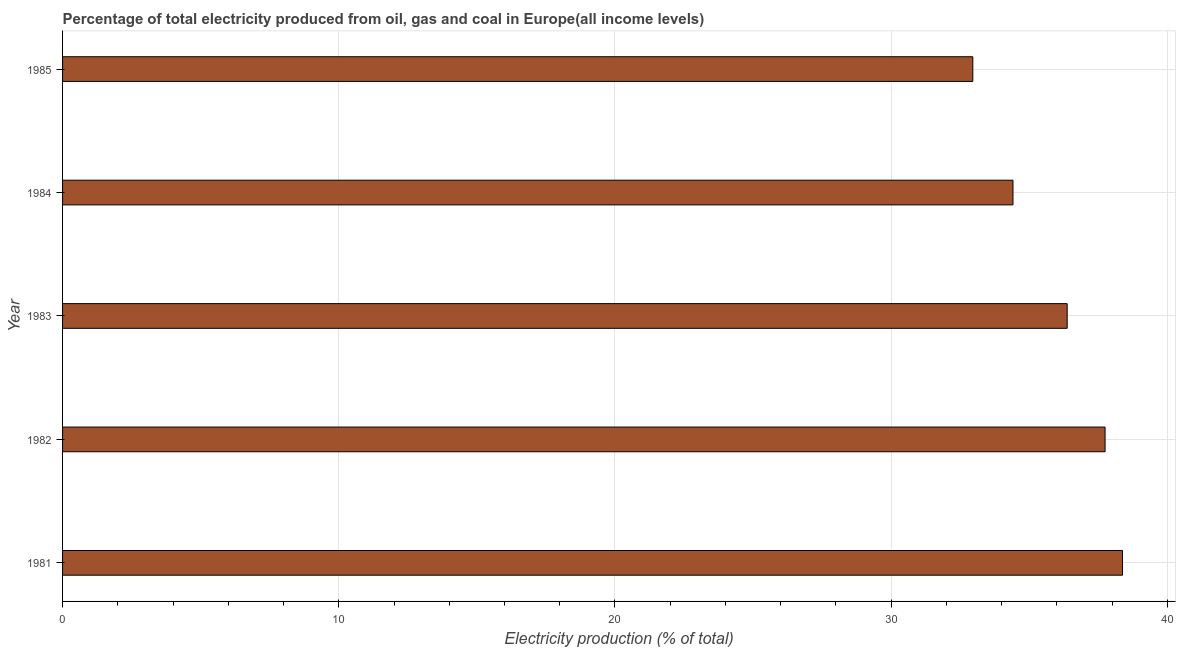Does the graph contain any zero values?
Give a very brief answer. No. What is the title of the graph?
Offer a terse response. Percentage of total electricity produced from oil, gas and coal in Europe(all income levels). What is the label or title of the X-axis?
Your answer should be very brief. Electricity production (% of total). What is the electricity production in 1985?
Your response must be concise. 32.95. Across all years, what is the maximum electricity production?
Keep it short and to the point. 38.37. Across all years, what is the minimum electricity production?
Provide a short and direct response. 32.95. In which year was the electricity production maximum?
Keep it short and to the point. 1981. In which year was the electricity production minimum?
Your answer should be very brief. 1985. What is the sum of the electricity production?
Keep it short and to the point. 179.85. What is the difference between the electricity production in 1984 and 1985?
Provide a succinct answer. 1.45. What is the average electricity production per year?
Your answer should be compact. 35.97. What is the median electricity production?
Ensure brevity in your answer.  36.37. Do a majority of the years between 1985 and 1981 (inclusive) have electricity production greater than 6 %?
Ensure brevity in your answer.  Yes. What is the ratio of the electricity production in 1981 to that in 1983?
Give a very brief answer. 1.05. What is the difference between the highest and the second highest electricity production?
Provide a short and direct response. 0.63. What is the difference between the highest and the lowest electricity production?
Ensure brevity in your answer.  5.42. How many years are there in the graph?
Your response must be concise. 5. What is the difference between two consecutive major ticks on the X-axis?
Offer a very short reply. 10. Are the values on the major ticks of X-axis written in scientific E-notation?
Your answer should be very brief. No. What is the Electricity production (% of total) of 1981?
Give a very brief answer. 38.37. What is the Electricity production (% of total) of 1982?
Ensure brevity in your answer.  37.74. What is the Electricity production (% of total) of 1983?
Provide a short and direct response. 36.37. What is the Electricity production (% of total) in 1984?
Your response must be concise. 34.41. What is the Electricity production (% of total) of 1985?
Your answer should be compact. 32.95. What is the difference between the Electricity production (% of total) in 1981 and 1982?
Offer a very short reply. 0.63. What is the difference between the Electricity production (% of total) in 1981 and 1983?
Provide a short and direct response. 2. What is the difference between the Electricity production (% of total) in 1981 and 1984?
Make the answer very short. 3.96. What is the difference between the Electricity production (% of total) in 1981 and 1985?
Your answer should be compact. 5.42. What is the difference between the Electricity production (% of total) in 1982 and 1983?
Keep it short and to the point. 1.37. What is the difference between the Electricity production (% of total) in 1982 and 1984?
Provide a short and direct response. 3.33. What is the difference between the Electricity production (% of total) in 1982 and 1985?
Your answer should be very brief. 4.79. What is the difference between the Electricity production (% of total) in 1983 and 1984?
Offer a terse response. 1.96. What is the difference between the Electricity production (% of total) in 1983 and 1985?
Your answer should be compact. 3.42. What is the difference between the Electricity production (% of total) in 1984 and 1985?
Your answer should be compact. 1.45. What is the ratio of the Electricity production (% of total) in 1981 to that in 1983?
Provide a succinct answer. 1.05. What is the ratio of the Electricity production (% of total) in 1981 to that in 1984?
Provide a succinct answer. 1.11. What is the ratio of the Electricity production (% of total) in 1981 to that in 1985?
Provide a short and direct response. 1.16. What is the ratio of the Electricity production (% of total) in 1982 to that in 1983?
Your answer should be very brief. 1.04. What is the ratio of the Electricity production (% of total) in 1982 to that in 1984?
Your answer should be very brief. 1.1. What is the ratio of the Electricity production (% of total) in 1982 to that in 1985?
Provide a short and direct response. 1.15. What is the ratio of the Electricity production (% of total) in 1983 to that in 1984?
Offer a very short reply. 1.06. What is the ratio of the Electricity production (% of total) in 1983 to that in 1985?
Your answer should be compact. 1.1. What is the ratio of the Electricity production (% of total) in 1984 to that in 1985?
Keep it short and to the point. 1.04. 